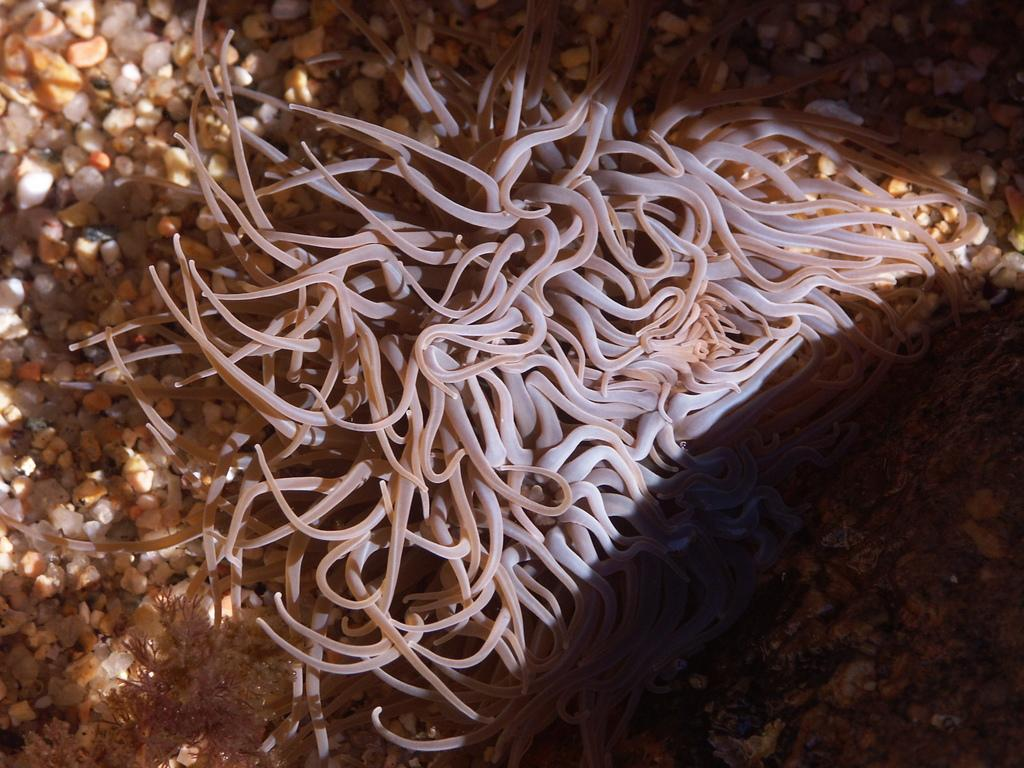What type of marine creature is in the water in the image? There is a sea anemone in the water in the image. What can be seen on the surface in the image? There is a surface with stones visible in the image. What type of celery can be seen growing near the stones in the image? There is no celery present in the image; it is a sea anemone in the water and a surface with stones. 